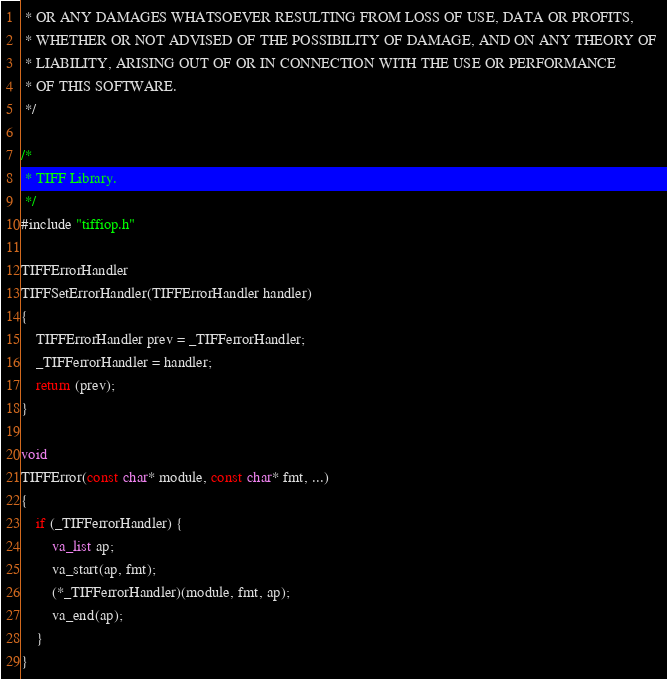Convert code to text. <code><loc_0><loc_0><loc_500><loc_500><_C_> * OR ANY DAMAGES WHATSOEVER RESULTING FROM LOSS OF USE, DATA OR PROFITS,
 * WHETHER OR NOT ADVISED OF THE POSSIBILITY OF DAMAGE, AND ON ANY THEORY OF 
 * LIABILITY, ARISING OUT OF OR IN CONNECTION WITH THE USE OR PERFORMANCE 
 * OF THIS SOFTWARE.
 */

/*
 * TIFF Library.
 */
#include "tiffiop.h"

TIFFErrorHandler
TIFFSetErrorHandler(TIFFErrorHandler handler)
{
	TIFFErrorHandler prev = _TIFFerrorHandler;
	_TIFFerrorHandler = handler;
	return (prev);
}

void
TIFFError(const char* module, const char* fmt, ...)
{
	if (_TIFFerrorHandler) {
		va_list ap;
		va_start(ap, fmt);
		(*_TIFFerrorHandler)(module, fmt, ap);
		va_end(ap);
	}
}
</code> 